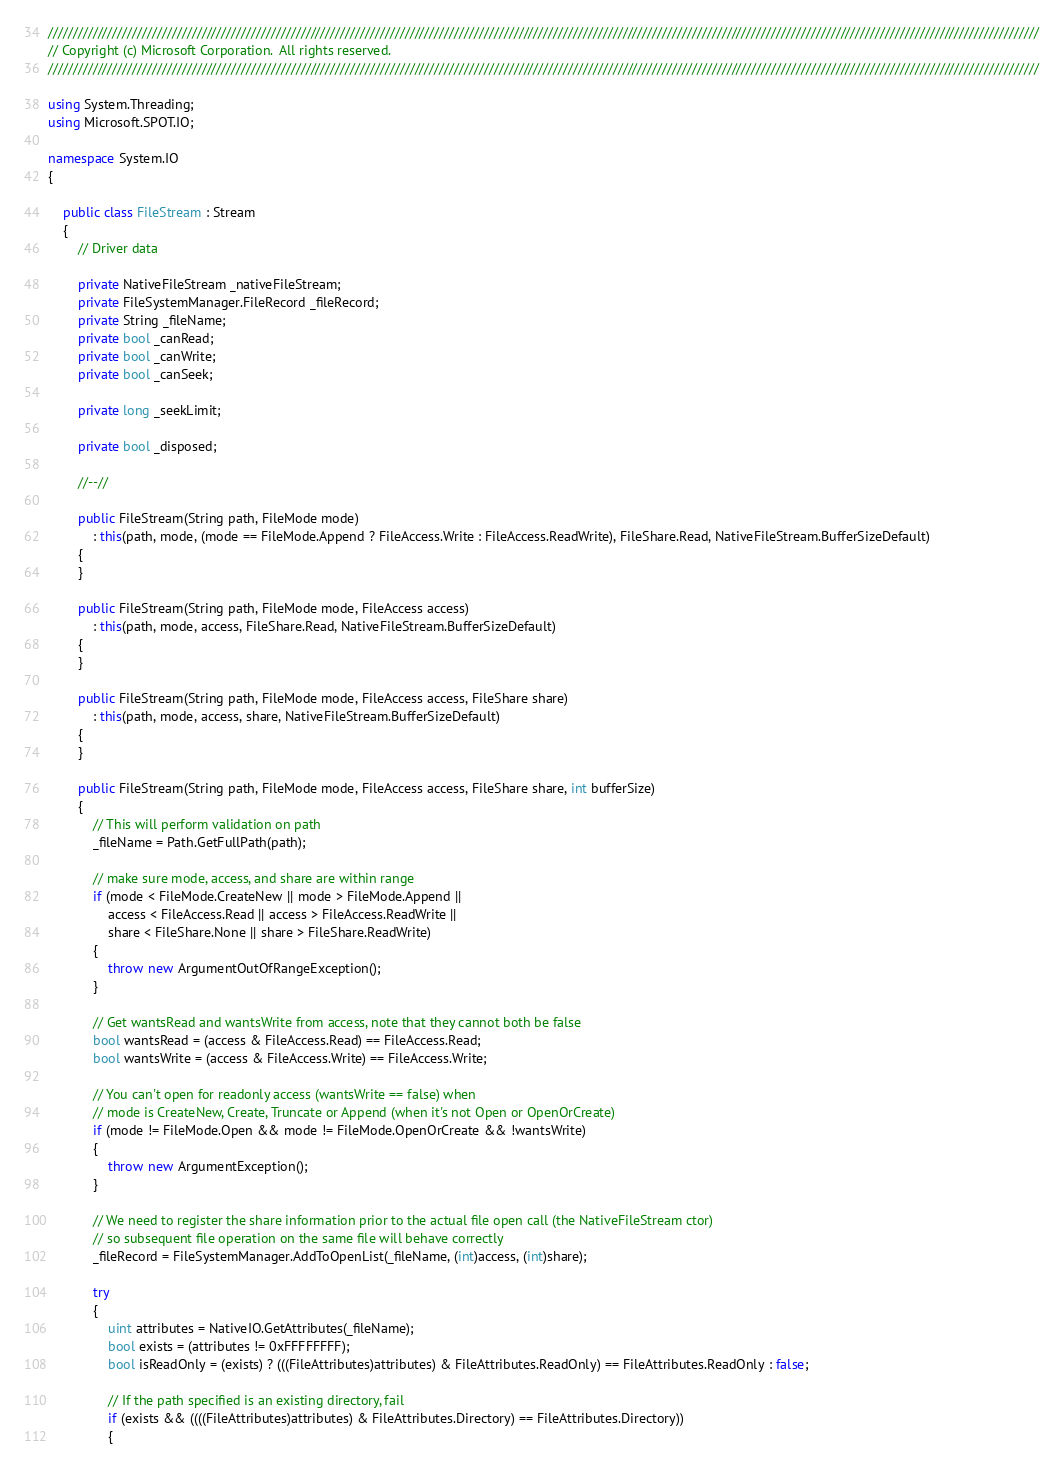Convert code to text. <code><loc_0><loc_0><loc_500><loc_500><_C#_>////////////////////////////////////////////////////////////////////////////////////////////////////////////////////////////////////////////////////////////////////////////////////////////////////////
// Copyright (c) Microsoft Corporation.  All rights reserved.
////////////////////////////////////////////////////////////////////////////////////////////////////////////////////////////////////////////////////////////////////////////////////////////////////////

using System.Threading;
using Microsoft.SPOT.IO;

namespace System.IO
{

    public class FileStream : Stream
    {
        // Driver data

        private NativeFileStream _nativeFileStream;
        private FileSystemManager.FileRecord _fileRecord;
        private String _fileName;
        private bool _canRead;
        private bool _canWrite;
        private bool _canSeek;

        private long _seekLimit;

        private bool _disposed;

        //--//

        public FileStream(String path, FileMode mode)
            : this(path, mode, (mode == FileMode.Append ? FileAccess.Write : FileAccess.ReadWrite), FileShare.Read, NativeFileStream.BufferSizeDefault)
        {
        }

        public FileStream(String path, FileMode mode, FileAccess access)
            : this(path, mode, access, FileShare.Read, NativeFileStream.BufferSizeDefault)
        {
        }

        public FileStream(String path, FileMode mode, FileAccess access, FileShare share)
            : this(path, mode, access, share, NativeFileStream.BufferSizeDefault)
        {
        }

        public FileStream(String path, FileMode mode, FileAccess access, FileShare share, int bufferSize)
        {
            // This will perform validation on path
            _fileName = Path.GetFullPath(path);

            // make sure mode, access, and share are within range
            if (mode < FileMode.CreateNew || mode > FileMode.Append ||
                access < FileAccess.Read || access > FileAccess.ReadWrite ||
                share < FileShare.None || share > FileShare.ReadWrite)
            {
                throw new ArgumentOutOfRangeException();
            }

            // Get wantsRead and wantsWrite from access, note that they cannot both be false
            bool wantsRead = (access & FileAccess.Read) == FileAccess.Read;
            bool wantsWrite = (access & FileAccess.Write) == FileAccess.Write;

            // You can't open for readonly access (wantsWrite == false) when
            // mode is CreateNew, Create, Truncate or Append (when it's not Open or OpenOrCreate)
            if (mode != FileMode.Open && mode != FileMode.OpenOrCreate && !wantsWrite)
            {
                throw new ArgumentException();
            }

            // We need to register the share information prior to the actual file open call (the NativeFileStream ctor)
            // so subsequent file operation on the same file will behave correctly
            _fileRecord = FileSystemManager.AddToOpenList(_fileName, (int)access, (int)share);

            try
            {
                uint attributes = NativeIO.GetAttributes(_fileName);
                bool exists = (attributes != 0xFFFFFFFF);
                bool isReadOnly = (exists) ? (((FileAttributes)attributes) & FileAttributes.ReadOnly) == FileAttributes.ReadOnly : false;

                // If the path specified is an existing directory, fail
                if (exists && ((((FileAttributes)attributes) & FileAttributes.Directory) == FileAttributes.Directory))
                {</code> 